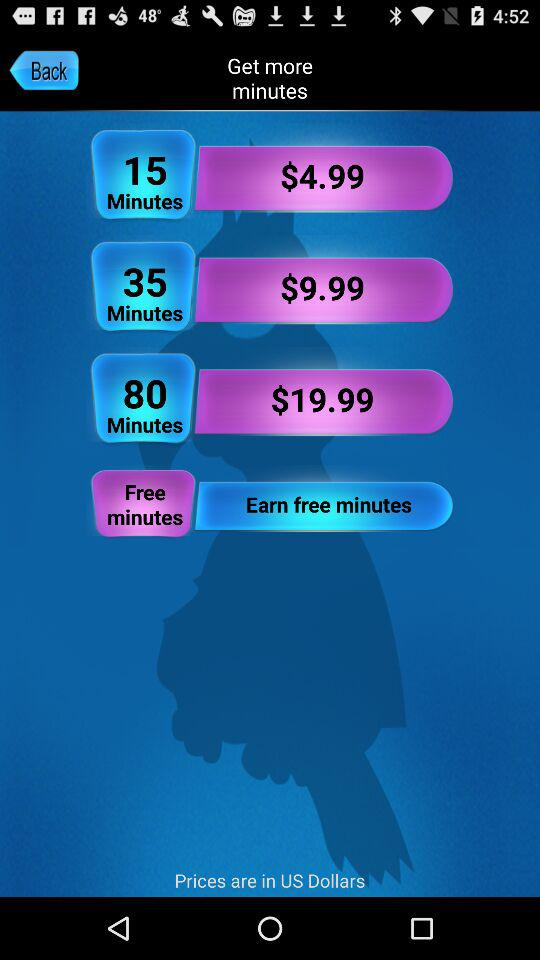What is the price of "15 Minutes"? The price of "15 Minutes" is $4.99. 